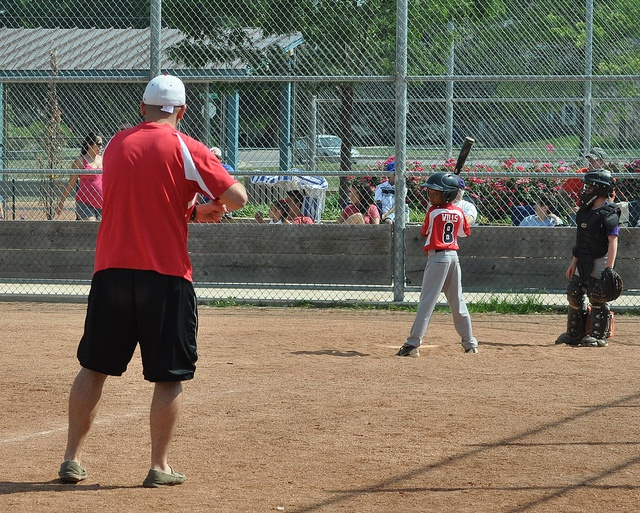Describe the objects in this image and their specific colors. I can see people in black, brown, and maroon tones, people in black, gray, maroon, and darkgray tones, people in black, gray, darkgray, and lightgray tones, people in black, gray, and brown tones, and people in black, gray, and darkgray tones in this image. 